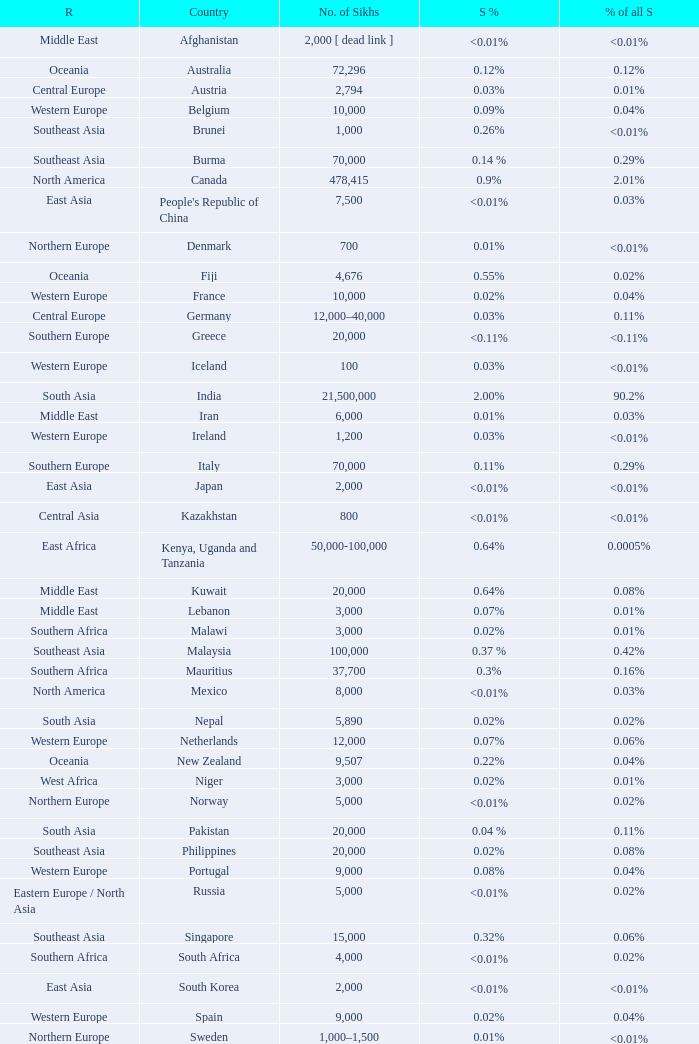What is the number of sikhs in Japan? 2000.0. 